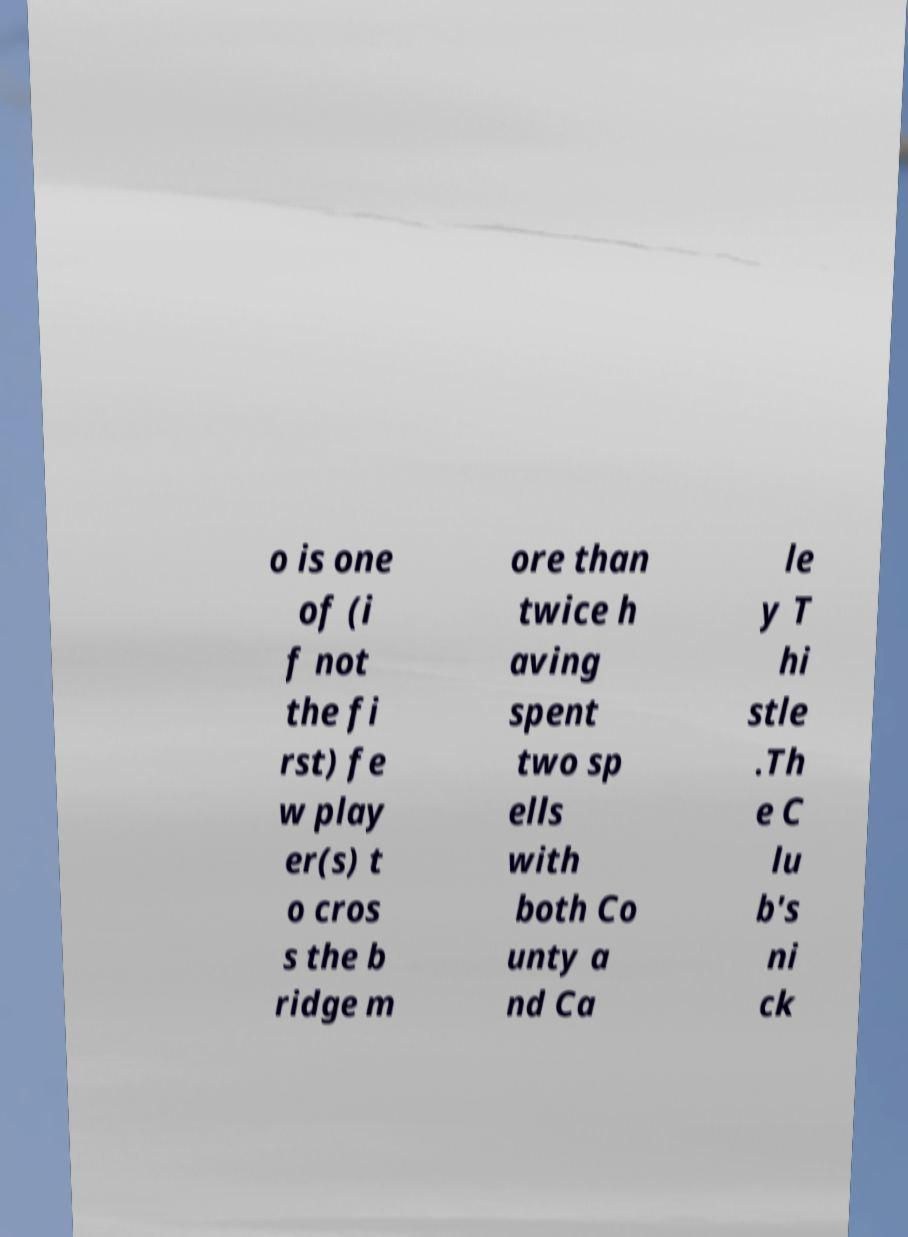What messages or text are displayed in this image? I need them in a readable, typed format. o is one of (i f not the fi rst) fe w play er(s) t o cros s the b ridge m ore than twice h aving spent two sp ells with both Co unty a nd Ca le y T hi stle .Th e C lu b's ni ck 